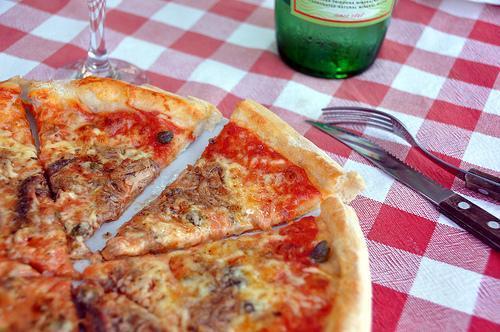How many glasses are on the table?
Give a very brief answer. 1. 